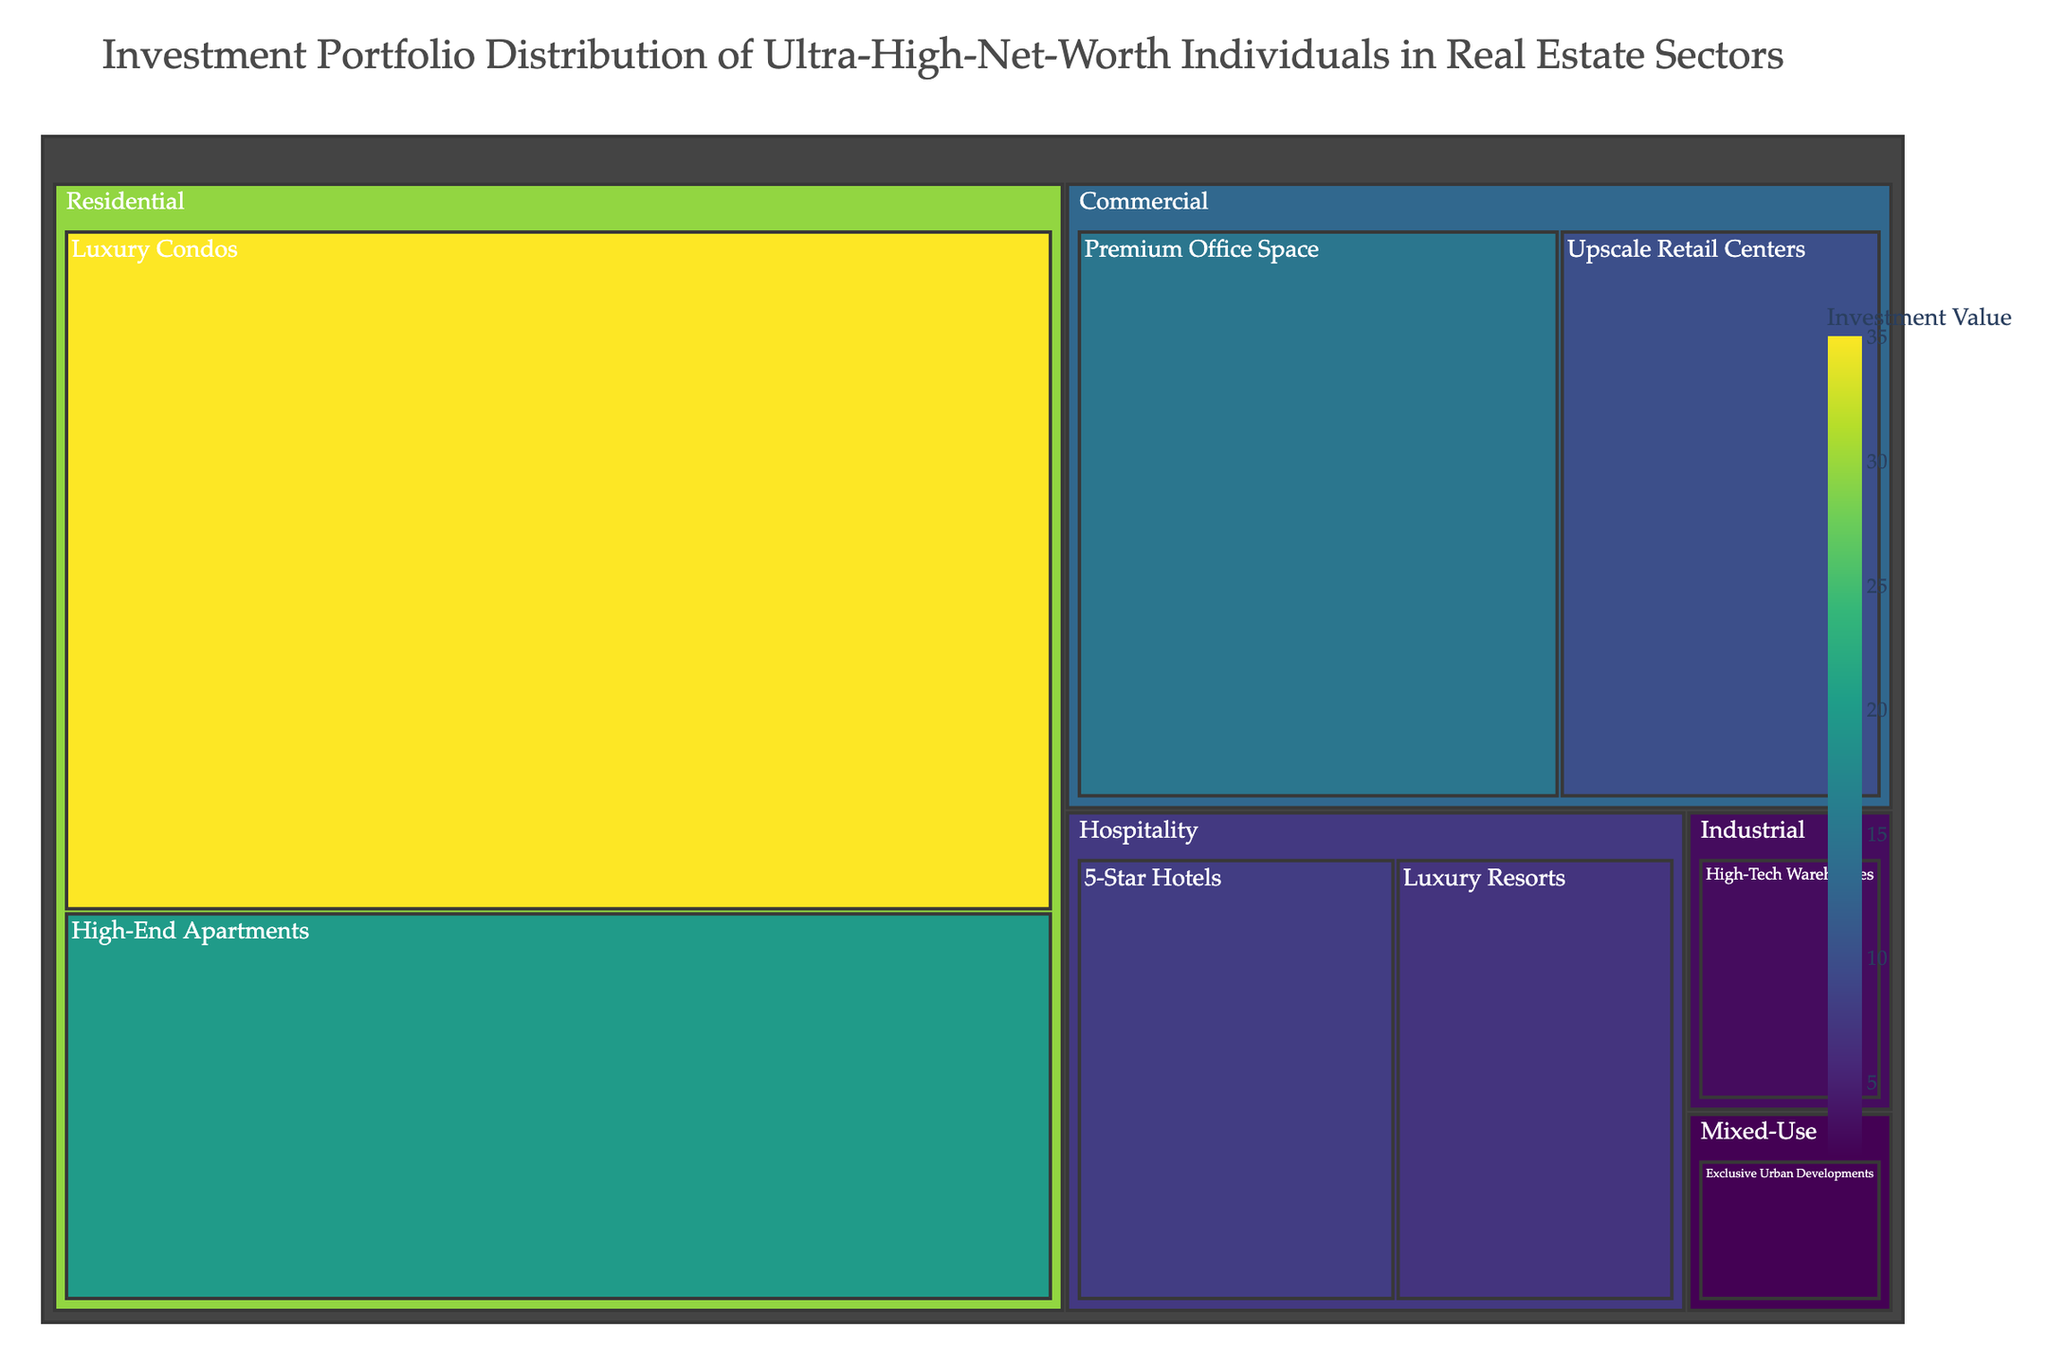What's the most heavily invested subsector in the Residential sector? The subsector with the largest value under the Residential sector is the most heavily invested. Looking at the treemap, Luxury Condos in the Residential sector has the largest value of 35.
Answer: Luxury Condos Which sector has the highest total investment? To determine this, sum the values of the subsectors within each sector and compare the totals. The Residential sector has Luxury Condos (35) and High-End Apartments (20), totaling 55. This is higher than any other sector's total.
Answer: Residential What's the combined investment value of Luxury Condos and 5-Star Hotels? Add the investment values of Luxury Condos (35) and 5-Star Hotels (8). This sum is 35 + 8 = 43.
Answer: 43 Which sector has the least total investment? To find this, compare the summed values of each sector. Mixed-Use has only one subsector, Exclusive Urban Developments, with a value of 2, which is the lowest among all sectors.
Answer: Mixed-Use Between Premium Office Space and Upscale Retail Centers, which has a higher investment value and by how much? Compare the values of Premium Office Space (15) and Upscale Retail Centers (10). The difference is 15 - 10 = 5.
Answer: Premium Office Space by 5 What is the total investment value in the Commercial sector? Sum the investment values of the subsectors within Commercial: Premium Office Space (15) and Upscale Retail Centers (10), which totals 15 + 10 = 25.
Answer: 25 How does the combined investment in Hospitality compare to Industrial? Add the values for Hospitality subsectors (5-Star Hotels: 8, Luxury Resorts: 7) and compare to the value for Industrial (High-Tech Warehouses: 3). Hospitality's total is 8 + 7 = 15, and 15 - 3 = 12 more than Industrial.
Answer: Hospitality has 12 more What is the investment value difference between High-End Apartments and Luxury Resorts? Subtract the value of Luxury Resorts (7) from High-End Apartments (20). The difference is 20 - 7 = 13.
Answer: 13 Which subsector has the lowest investment value, and which sector does it belong to? Examine the values of all subsectors to find the smallest one. Exclusive Urban Developments has the lowest value of 2, and it belongs to the Mixed-Use sector.
Answer: Exclusive Urban Developments, Mixed-Use 